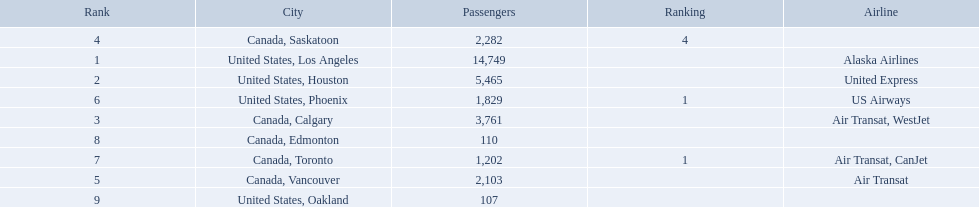Give me the full table as a dictionary. {'header': ['Rank', 'City', 'Passengers', 'Ranking', 'Airline'], 'rows': [['4', 'Canada, Saskatoon', '2,282', '4', ''], ['1', 'United States, Los Angeles', '14,749', '', 'Alaska Airlines'], ['2', 'United States, Houston', '5,465', '', 'United Express'], ['6', 'United States, Phoenix', '1,829', '1', 'US Airways'], ['3', 'Canada, Calgary', '3,761', '', 'Air Transat, WestJet'], ['8', 'Canada, Edmonton', '110', '', ''], ['7', 'Canada, Toronto', '1,202', '1', 'Air Transat, CanJet'], ['5', 'Canada, Vancouver', '2,103', '', 'Air Transat'], ['9', 'United States, Oakland', '107', '', '']]} Which airport has the least amount of passengers? 107. What airport has 107 passengers? United States, Oakland. Where are the destinations of the airport? United States, Los Angeles, United States, Houston, Canada, Calgary, Canada, Saskatoon, Canada, Vancouver, United States, Phoenix, Canada, Toronto, Canada, Edmonton, United States, Oakland. What is the number of passengers to phoenix? 1,829. 